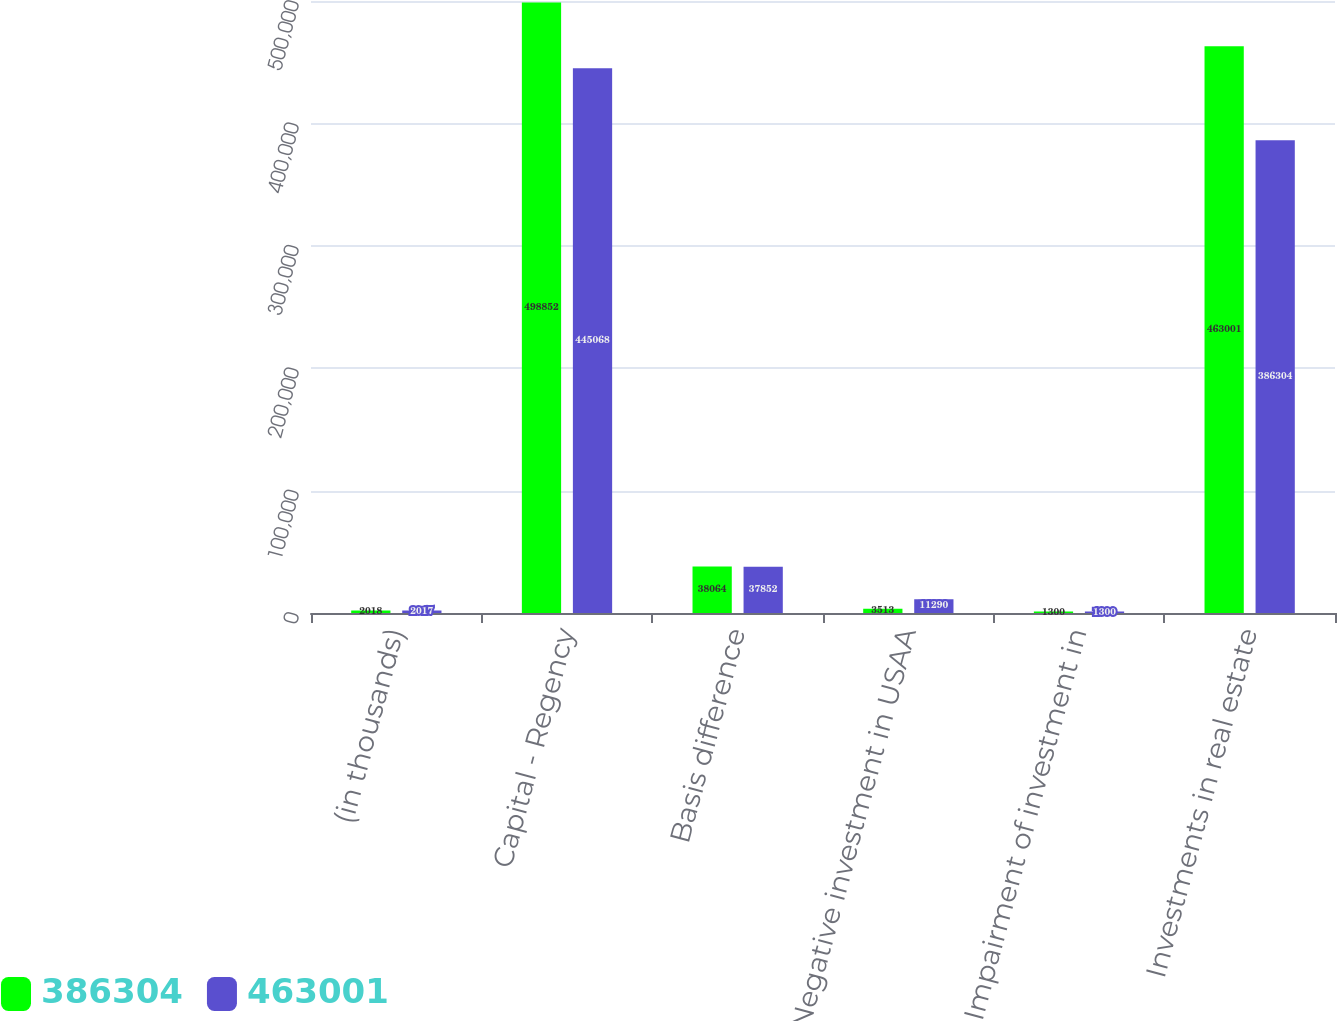Convert chart to OTSL. <chart><loc_0><loc_0><loc_500><loc_500><stacked_bar_chart><ecel><fcel>(in thousands)<fcel>Capital - Regency<fcel>Basis difference<fcel>Negative investment in USAA<fcel>Impairment of investment in<fcel>Investments in real estate<nl><fcel>386304<fcel>2018<fcel>498852<fcel>38064<fcel>3513<fcel>1300<fcel>463001<nl><fcel>463001<fcel>2017<fcel>445068<fcel>37852<fcel>11290<fcel>1300<fcel>386304<nl></chart> 